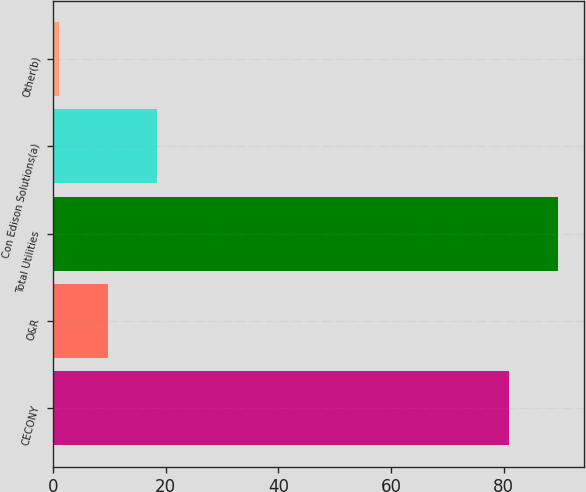<chart> <loc_0><loc_0><loc_500><loc_500><bar_chart><fcel>CECONY<fcel>O&R<fcel>Total Utilities<fcel>Con Edison Solutions(a)<fcel>Other(b)<nl><fcel>81<fcel>9.7<fcel>89.7<fcel>18.4<fcel>1<nl></chart> 